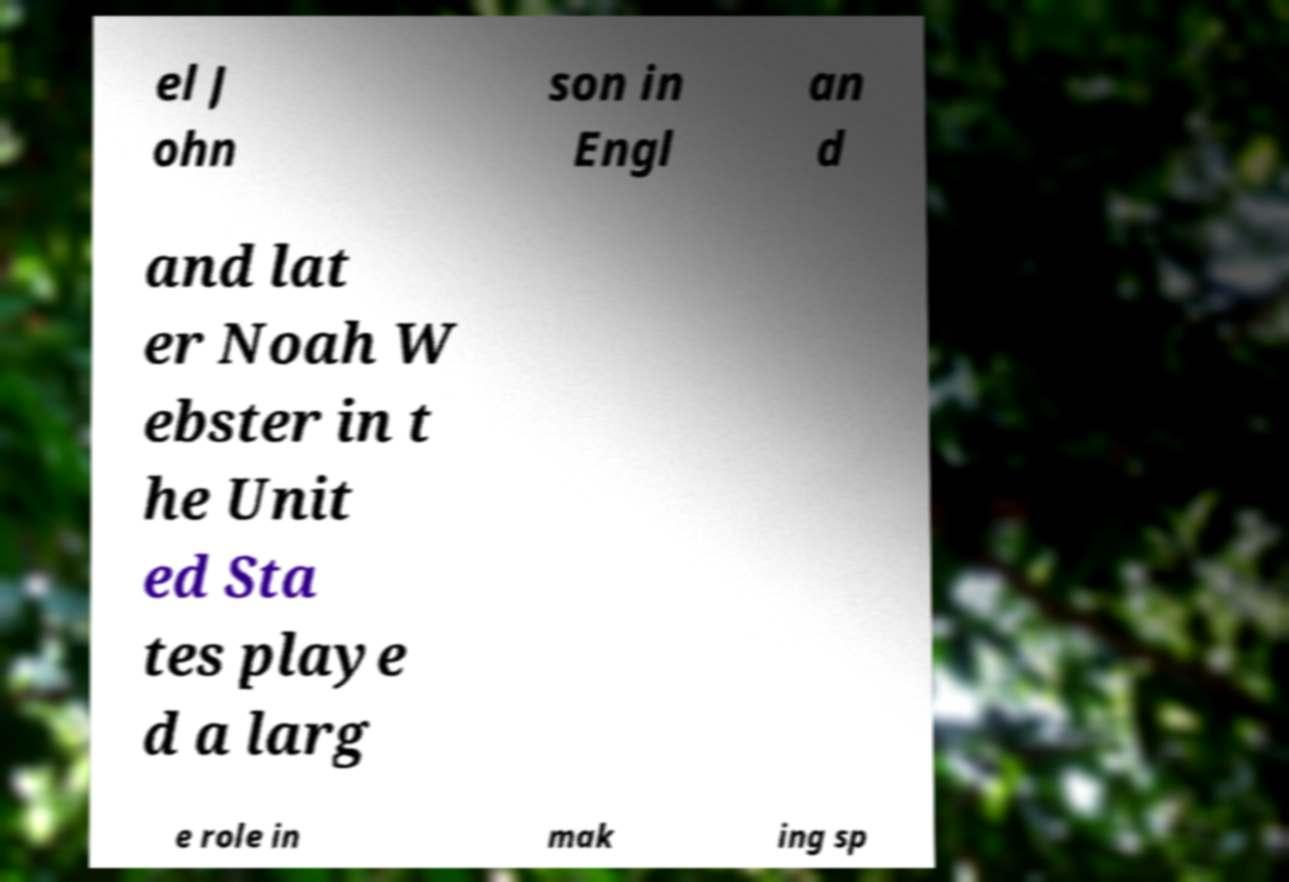What messages or text are displayed in this image? I need them in a readable, typed format. el J ohn son in Engl an d and lat er Noah W ebster in t he Unit ed Sta tes playe d a larg e role in mak ing sp 